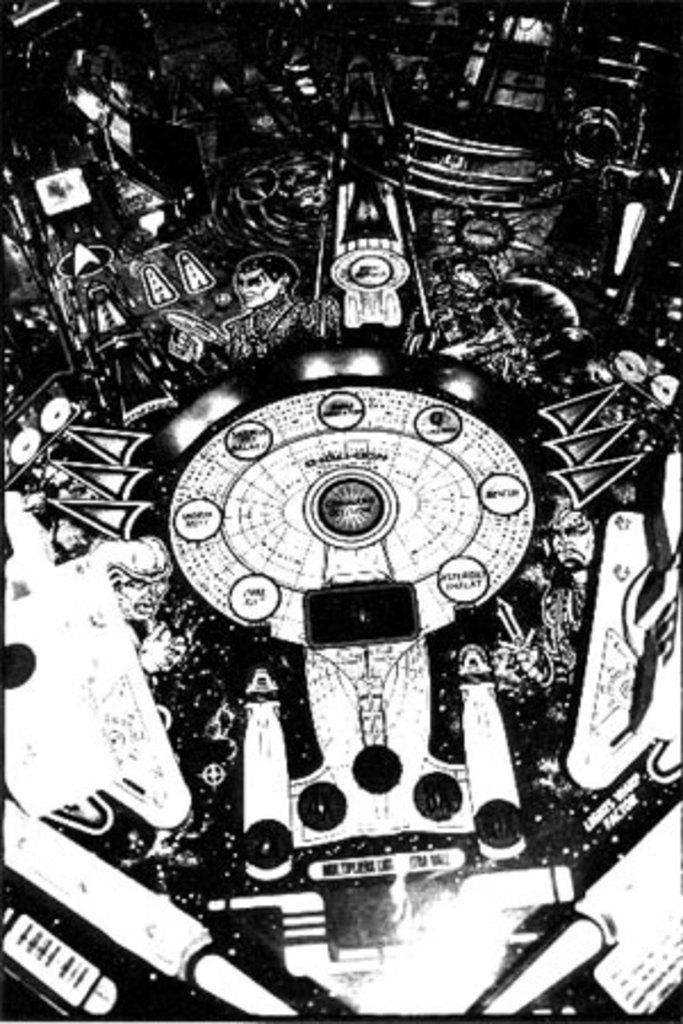What is the color scheme of the image? The image is a black and white photo. How many people are in the photo? There are four persons in the photo. Can you describe any other items visible in the photo besides the people? Unfortunately, the provided facts do not specify any other items visible in the photo. What shape is the cellar in the image? There is no cellar present in the image, so it is not possible to determine its shape. 